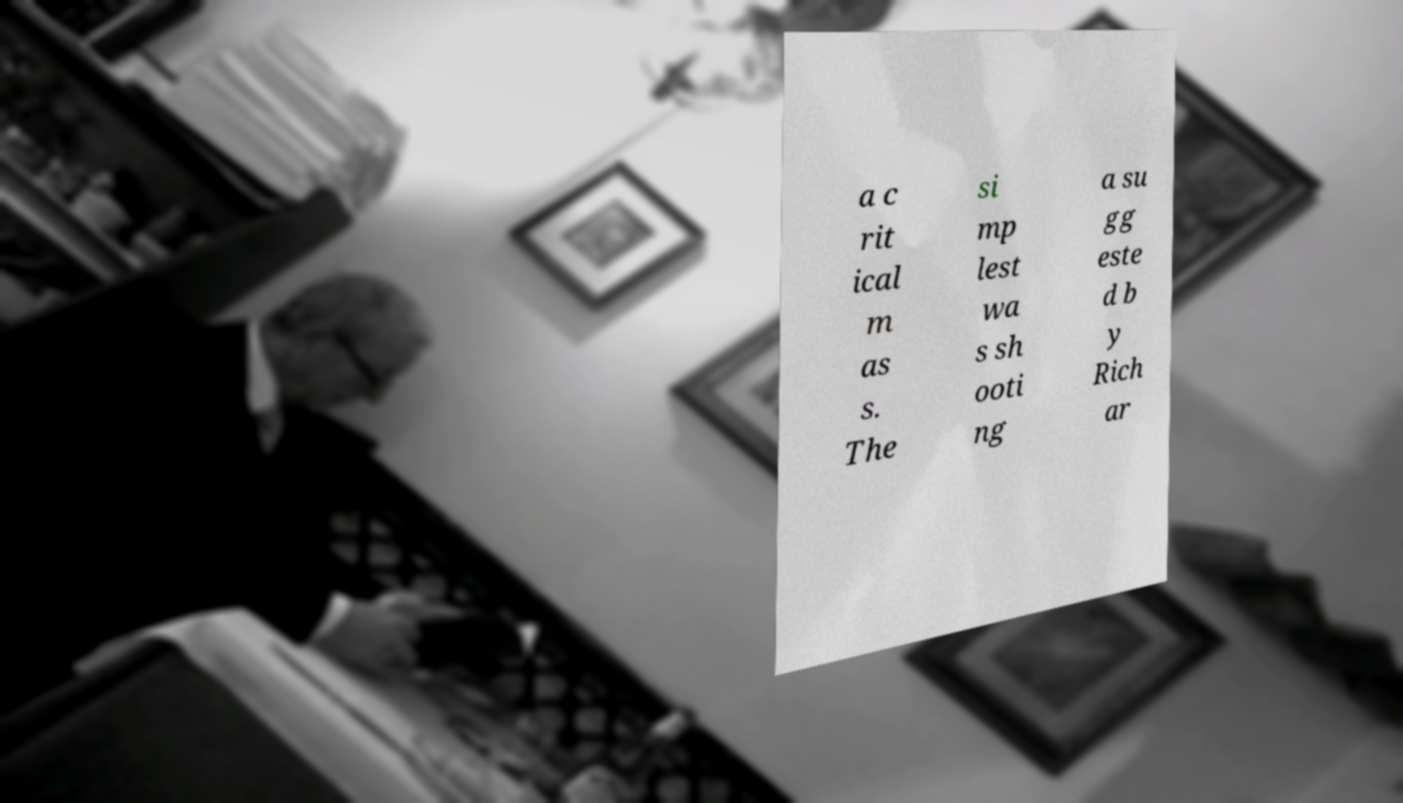Can you read and provide the text displayed in the image?This photo seems to have some interesting text. Can you extract and type it out for me? a c rit ical m as s. The si mp lest wa s sh ooti ng a su gg este d b y Rich ar 